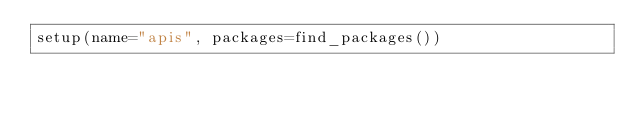Convert code to text. <code><loc_0><loc_0><loc_500><loc_500><_Python_>setup(name="apis", packages=find_packages())</code> 